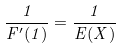Convert formula to latex. <formula><loc_0><loc_0><loc_500><loc_500>\frac { 1 } { F ^ { \prime } ( 1 ) } = \frac { 1 } { E ( X ) }</formula> 